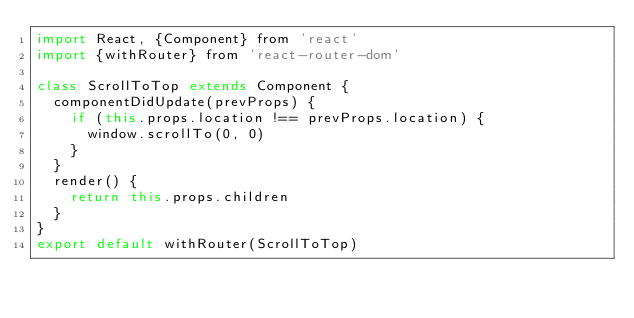<code> <loc_0><loc_0><loc_500><loc_500><_JavaScript_>import React, {Component} from 'react'
import {withRouter} from 'react-router-dom'

class ScrollToTop extends Component {
  componentDidUpdate(prevProps) {
    if (this.props.location !== prevProps.location) {
      window.scrollTo(0, 0)
    }
  }
  render() {
    return this.props.children
  }
}
export default withRouter(ScrollToTop)
</code> 